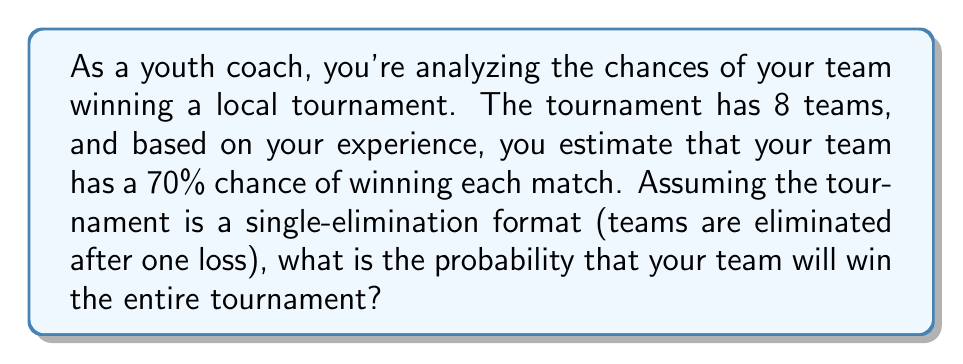Could you help me with this problem? Let's approach this step-by-step:

1) In a single-elimination tournament with 8 teams, a team needs to win 3 consecutive matches to be the champion:
   - Quarter-final
   - Semi-final
   - Final

2) The probability of winning each individual match is 0.7 or 70%.

3) To win the tournament, the team must win all three matches. This is a series of independent events, so we multiply the probabilities:

   $$P(\text{winning tournament}) = P(\text{win QF}) \times P(\text{win SF}) \times P(\text{win F})$$

4) Substituting the probabilities:

   $$P(\text{winning tournament}) = 0.7 \times 0.7 \times 0.7$$

5) Calculating:

   $$P(\text{winning tournament}) = 0.7^3 = 0.343$$

6) Converting to a percentage:

   $$0.343 \times 100\% = 34.3\%$$

Therefore, the probability of your team winning the entire tournament is approximately 34.3%.
Answer: $0.343$ or $34.3\%$ 